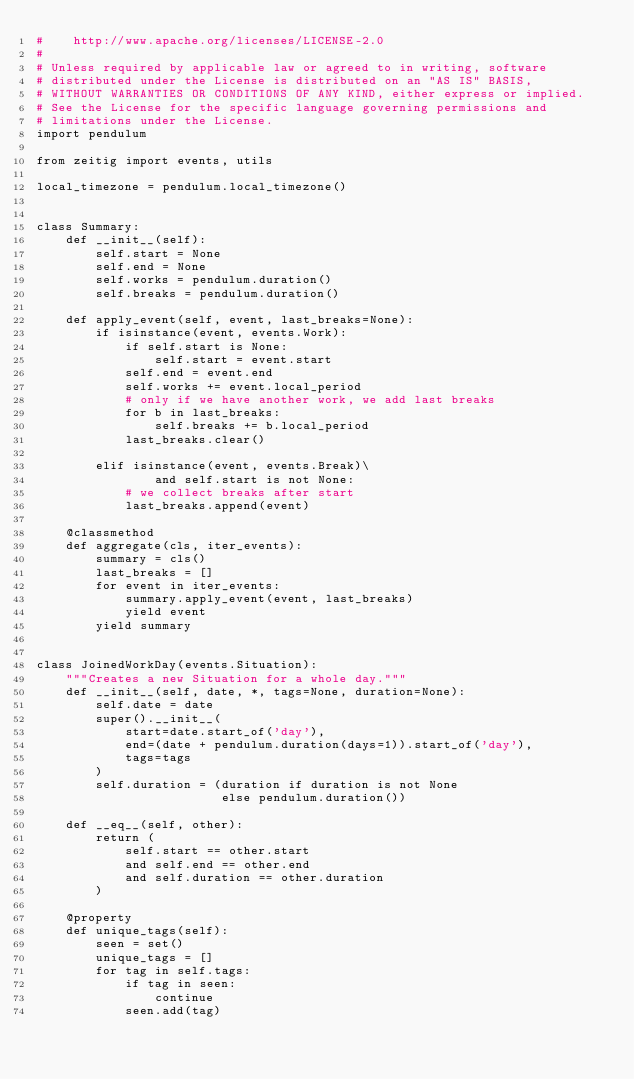Convert code to text. <code><loc_0><loc_0><loc_500><loc_500><_Python_>#    http://www.apache.org/licenses/LICENSE-2.0
#
# Unless required by applicable law or agreed to in writing, software
# distributed under the License is distributed on an "AS IS" BASIS,
# WITHOUT WARRANTIES OR CONDITIONS OF ANY KIND, either express or implied.
# See the License for the specific language governing permissions and
# limitations under the License.
import pendulum

from zeitig import events, utils

local_timezone = pendulum.local_timezone()


class Summary:
    def __init__(self):
        self.start = None
        self.end = None
        self.works = pendulum.duration()
        self.breaks = pendulum.duration()

    def apply_event(self, event, last_breaks=None):
        if isinstance(event, events.Work):
            if self.start is None:
                self.start = event.start
            self.end = event.end
            self.works += event.local_period
            # only if we have another work, we add last breaks
            for b in last_breaks:
                self.breaks += b.local_period
            last_breaks.clear()

        elif isinstance(event, events.Break)\
                and self.start is not None:
            # we collect breaks after start
            last_breaks.append(event)

    @classmethod
    def aggregate(cls, iter_events):
        summary = cls()
        last_breaks = []
        for event in iter_events:
            summary.apply_event(event, last_breaks)
            yield event
        yield summary


class JoinedWorkDay(events.Situation):
    """Creates a new Situation for a whole day."""
    def __init__(self, date, *, tags=None, duration=None):
        self.date = date
        super().__init__(
            start=date.start_of('day'),
            end=(date + pendulum.duration(days=1)).start_of('day'),
            tags=tags
        )
        self.duration = (duration if duration is not None
                         else pendulum.duration())

    def __eq__(self, other):
        return (
            self.start == other.start
            and self.end == other.end
            and self.duration == other.duration
        )

    @property
    def unique_tags(self):
        seen = set()
        unique_tags = []
        for tag in self.tags:
            if tag in seen:
                continue
            seen.add(tag)</code> 